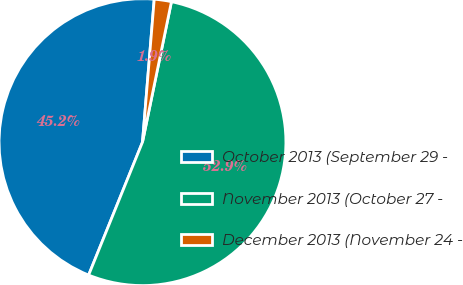Convert chart. <chart><loc_0><loc_0><loc_500><loc_500><pie_chart><fcel>October 2013 (September 29 -<fcel>November 2013 (October 27 -<fcel>December 2013 (November 24 -<nl><fcel>45.18%<fcel>52.89%<fcel>1.93%<nl></chart> 